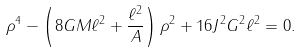<formula> <loc_0><loc_0><loc_500><loc_500>\rho ^ { 4 } - \left ( 8 G M \ell ^ { 2 } + \frac { \ell ^ { 2 } } { A } \right ) \rho ^ { 2 } + 1 6 J ^ { 2 } G ^ { 2 } \ell ^ { 2 } = 0 .</formula> 